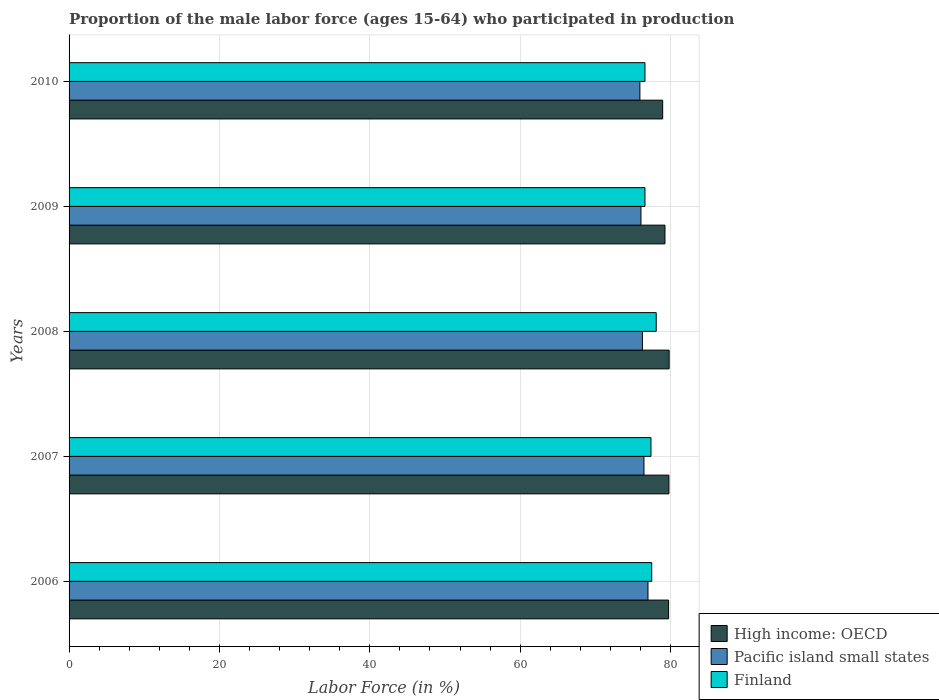How many groups of bars are there?
Your answer should be very brief. 5. Are the number of bars per tick equal to the number of legend labels?
Ensure brevity in your answer.  Yes. Are the number of bars on each tick of the Y-axis equal?
Your response must be concise. Yes. How many bars are there on the 3rd tick from the top?
Your answer should be very brief. 3. In how many cases, is the number of bars for a given year not equal to the number of legend labels?
Give a very brief answer. 0. What is the proportion of the male labor force who participated in production in Finland in 2008?
Offer a terse response. 78.1. Across all years, what is the maximum proportion of the male labor force who participated in production in Finland?
Your response must be concise. 78.1. Across all years, what is the minimum proportion of the male labor force who participated in production in High income: OECD?
Keep it short and to the point. 78.96. In which year was the proportion of the male labor force who participated in production in High income: OECD maximum?
Provide a succinct answer. 2008. What is the total proportion of the male labor force who participated in production in Finland in the graph?
Ensure brevity in your answer.  386.2. What is the difference between the proportion of the male labor force who participated in production in Pacific island small states in 2009 and that in 2010?
Your answer should be compact. 0.14. What is the difference between the proportion of the male labor force who participated in production in Pacific island small states in 2010 and the proportion of the male labor force who participated in production in High income: OECD in 2007?
Ensure brevity in your answer.  -3.86. What is the average proportion of the male labor force who participated in production in High income: OECD per year?
Keep it short and to the point. 79.52. In the year 2010, what is the difference between the proportion of the male labor force who participated in production in Finland and proportion of the male labor force who participated in production in High income: OECD?
Provide a succinct answer. -2.36. What is the ratio of the proportion of the male labor force who participated in production in Finland in 2006 to that in 2007?
Offer a terse response. 1. What is the difference between the highest and the second highest proportion of the male labor force who participated in production in Pacific island small states?
Offer a very short reply. 0.54. What is the difference between the highest and the lowest proportion of the male labor force who participated in production in Pacific island small states?
Ensure brevity in your answer.  1.08. What does the 2nd bar from the top in 2007 represents?
Give a very brief answer. Pacific island small states. What does the 1st bar from the bottom in 2010 represents?
Your answer should be compact. High income: OECD. How many bars are there?
Your response must be concise. 15. What is the difference between two consecutive major ticks on the X-axis?
Keep it short and to the point. 20. Are the values on the major ticks of X-axis written in scientific E-notation?
Provide a succinct answer. No. Does the graph contain any zero values?
Make the answer very short. No. Does the graph contain grids?
Give a very brief answer. Yes. Where does the legend appear in the graph?
Offer a terse response. Bottom right. How many legend labels are there?
Provide a succinct answer. 3. How are the legend labels stacked?
Your answer should be very brief. Vertical. What is the title of the graph?
Your answer should be very brief. Proportion of the male labor force (ages 15-64) who participated in production. Does "Saudi Arabia" appear as one of the legend labels in the graph?
Make the answer very short. No. What is the Labor Force (in %) in High income: OECD in 2006?
Provide a short and direct response. 79.75. What is the Labor Force (in %) of Pacific island small states in 2006?
Provide a succinct answer. 77. What is the Labor Force (in %) in Finland in 2006?
Provide a succinct answer. 77.5. What is the Labor Force (in %) in High income: OECD in 2007?
Ensure brevity in your answer.  79.79. What is the Labor Force (in %) of Pacific island small states in 2007?
Your answer should be compact. 76.47. What is the Labor Force (in %) in Finland in 2007?
Offer a very short reply. 77.4. What is the Labor Force (in %) in High income: OECD in 2008?
Your response must be concise. 79.82. What is the Labor Force (in %) of Pacific island small states in 2008?
Offer a very short reply. 76.26. What is the Labor Force (in %) in Finland in 2008?
Ensure brevity in your answer.  78.1. What is the Labor Force (in %) of High income: OECD in 2009?
Make the answer very short. 79.26. What is the Labor Force (in %) in Pacific island small states in 2009?
Your response must be concise. 76.07. What is the Labor Force (in %) in Finland in 2009?
Ensure brevity in your answer.  76.6. What is the Labor Force (in %) of High income: OECD in 2010?
Offer a very short reply. 78.96. What is the Labor Force (in %) in Pacific island small states in 2010?
Give a very brief answer. 75.93. What is the Labor Force (in %) of Finland in 2010?
Offer a very short reply. 76.6. Across all years, what is the maximum Labor Force (in %) in High income: OECD?
Provide a short and direct response. 79.82. Across all years, what is the maximum Labor Force (in %) of Pacific island small states?
Your answer should be very brief. 77. Across all years, what is the maximum Labor Force (in %) of Finland?
Offer a terse response. 78.1. Across all years, what is the minimum Labor Force (in %) of High income: OECD?
Make the answer very short. 78.96. Across all years, what is the minimum Labor Force (in %) of Pacific island small states?
Your answer should be very brief. 75.93. Across all years, what is the minimum Labor Force (in %) in Finland?
Make the answer very short. 76.6. What is the total Labor Force (in %) in High income: OECD in the graph?
Your answer should be very brief. 397.58. What is the total Labor Force (in %) in Pacific island small states in the graph?
Keep it short and to the point. 381.73. What is the total Labor Force (in %) of Finland in the graph?
Provide a short and direct response. 386.2. What is the difference between the Labor Force (in %) in High income: OECD in 2006 and that in 2007?
Your answer should be compact. -0.05. What is the difference between the Labor Force (in %) of Pacific island small states in 2006 and that in 2007?
Make the answer very short. 0.54. What is the difference between the Labor Force (in %) of Finland in 2006 and that in 2007?
Your response must be concise. 0.1. What is the difference between the Labor Force (in %) of High income: OECD in 2006 and that in 2008?
Give a very brief answer. -0.07. What is the difference between the Labor Force (in %) of Pacific island small states in 2006 and that in 2008?
Your answer should be compact. 0.74. What is the difference between the Labor Force (in %) in Finland in 2006 and that in 2008?
Provide a short and direct response. -0.6. What is the difference between the Labor Force (in %) in High income: OECD in 2006 and that in 2009?
Keep it short and to the point. 0.48. What is the difference between the Labor Force (in %) of Pacific island small states in 2006 and that in 2009?
Provide a succinct answer. 0.94. What is the difference between the Labor Force (in %) of High income: OECD in 2006 and that in 2010?
Offer a terse response. 0.79. What is the difference between the Labor Force (in %) in Pacific island small states in 2006 and that in 2010?
Your response must be concise. 1.08. What is the difference between the Labor Force (in %) of High income: OECD in 2007 and that in 2008?
Provide a short and direct response. -0.03. What is the difference between the Labor Force (in %) of Pacific island small states in 2007 and that in 2008?
Your answer should be compact. 0.21. What is the difference between the Labor Force (in %) in Finland in 2007 and that in 2008?
Provide a short and direct response. -0.7. What is the difference between the Labor Force (in %) of High income: OECD in 2007 and that in 2009?
Your response must be concise. 0.53. What is the difference between the Labor Force (in %) in Pacific island small states in 2007 and that in 2009?
Give a very brief answer. 0.4. What is the difference between the Labor Force (in %) of High income: OECD in 2007 and that in 2010?
Offer a terse response. 0.83. What is the difference between the Labor Force (in %) in Pacific island small states in 2007 and that in 2010?
Your answer should be compact. 0.54. What is the difference between the Labor Force (in %) in Finland in 2007 and that in 2010?
Your answer should be very brief. 0.8. What is the difference between the Labor Force (in %) in High income: OECD in 2008 and that in 2009?
Make the answer very short. 0.56. What is the difference between the Labor Force (in %) of Pacific island small states in 2008 and that in 2009?
Provide a short and direct response. 0.19. What is the difference between the Labor Force (in %) in Finland in 2008 and that in 2009?
Offer a very short reply. 1.5. What is the difference between the Labor Force (in %) of High income: OECD in 2008 and that in 2010?
Give a very brief answer. 0.86. What is the difference between the Labor Force (in %) in Pacific island small states in 2008 and that in 2010?
Make the answer very short. 0.34. What is the difference between the Labor Force (in %) in High income: OECD in 2009 and that in 2010?
Provide a short and direct response. 0.31. What is the difference between the Labor Force (in %) of Pacific island small states in 2009 and that in 2010?
Offer a terse response. 0.14. What is the difference between the Labor Force (in %) in Finland in 2009 and that in 2010?
Your response must be concise. 0. What is the difference between the Labor Force (in %) in High income: OECD in 2006 and the Labor Force (in %) in Pacific island small states in 2007?
Provide a short and direct response. 3.28. What is the difference between the Labor Force (in %) in High income: OECD in 2006 and the Labor Force (in %) in Finland in 2007?
Your response must be concise. 2.35. What is the difference between the Labor Force (in %) in Pacific island small states in 2006 and the Labor Force (in %) in Finland in 2007?
Provide a short and direct response. -0.4. What is the difference between the Labor Force (in %) of High income: OECD in 2006 and the Labor Force (in %) of Pacific island small states in 2008?
Provide a succinct answer. 3.48. What is the difference between the Labor Force (in %) of High income: OECD in 2006 and the Labor Force (in %) of Finland in 2008?
Provide a short and direct response. 1.65. What is the difference between the Labor Force (in %) of Pacific island small states in 2006 and the Labor Force (in %) of Finland in 2008?
Keep it short and to the point. -1.1. What is the difference between the Labor Force (in %) of High income: OECD in 2006 and the Labor Force (in %) of Pacific island small states in 2009?
Provide a short and direct response. 3.68. What is the difference between the Labor Force (in %) in High income: OECD in 2006 and the Labor Force (in %) in Finland in 2009?
Provide a short and direct response. 3.15. What is the difference between the Labor Force (in %) in Pacific island small states in 2006 and the Labor Force (in %) in Finland in 2009?
Ensure brevity in your answer.  0.4. What is the difference between the Labor Force (in %) in High income: OECD in 2006 and the Labor Force (in %) in Pacific island small states in 2010?
Give a very brief answer. 3.82. What is the difference between the Labor Force (in %) in High income: OECD in 2006 and the Labor Force (in %) in Finland in 2010?
Provide a short and direct response. 3.15. What is the difference between the Labor Force (in %) in Pacific island small states in 2006 and the Labor Force (in %) in Finland in 2010?
Your answer should be very brief. 0.4. What is the difference between the Labor Force (in %) in High income: OECD in 2007 and the Labor Force (in %) in Pacific island small states in 2008?
Give a very brief answer. 3.53. What is the difference between the Labor Force (in %) of High income: OECD in 2007 and the Labor Force (in %) of Finland in 2008?
Keep it short and to the point. 1.69. What is the difference between the Labor Force (in %) of Pacific island small states in 2007 and the Labor Force (in %) of Finland in 2008?
Make the answer very short. -1.63. What is the difference between the Labor Force (in %) in High income: OECD in 2007 and the Labor Force (in %) in Pacific island small states in 2009?
Give a very brief answer. 3.72. What is the difference between the Labor Force (in %) of High income: OECD in 2007 and the Labor Force (in %) of Finland in 2009?
Keep it short and to the point. 3.19. What is the difference between the Labor Force (in %) of Pacific island small states in 2007 and the Labor Force (in %) of Finland in 2009?
Make the answer very short. -0.13. What is the difference between the Labor Force (in %) of High income: OECD in 2007 and the Labor Force (in %) of Pacific island small states in 2010?
Offer a very short reply. 3.86. What is the difference between the Labor Force (in %) in High income: OECD in 2007 and the Labor Force (in %) in Finland in 2010?
Keep it short and to the point. 3.19. What is the difference between the Labor Force (in %) in Pacific island small states in 2007 and the Labor Force (in %) in Finland in 2010?
Provide a short and direct response. -0.13. What is the difference between the Labor Force (in %) in High income: OECD in 2008 and the Labor Force (in %) in Pacific island small states in 2009?
Your response must be concise. 3.75. What is the difference between the Labor Force (in %) in High income: OECD in 2008 and the Labor Force (in %) in Finland in 2009?
Provide a succinct answer. 3.22. What is the difference between the Labor Force (in %) in Pacific island small states in 2008 and the Labor Force (in %) in Finland in 2009?
Offer a terse response. -0.34. What is the difference between the Labor Force (in %) of High income: OECD in 2008 and the Labor Force (in %) of Pacific island small states in 2010?
Offer a terse response. 3.89. What is the difference between the Labor Force (in %) in High income: OECD in 2008 and the Labor Force (in %) in Finland in 2010?
Ensure brevity in your answer.  3.22. What is the difference between the Labor Force (in %) of Pacific island small states in 2008 and the Labor Force (in %) of Finland in 2010?
Your answer should be very brief. -0.34. What is the difference between the Labor Force (in %) in High income: OECD in 2009 and the Labor Force (in %) in Pacific island small states in 2010?
Your response must be concise. 3.34. What is the difference between the Labor Force (in %) of High income: OECD in 2009 and the Labor Force (in %) of Finland in 2010?
Make the answer very short. 2.66. What is the difference between the Labor Force (in %) of Pacific island small states in 2009 and the Labor Force (in %) of Finland in 2010?
Your response must be concise. -0.53. What is the average Labor Force (in %) in High income: OECD per year?
Your answer should be compact. 79.52. What is the average Labor Force (in %) of Pacific island small states per year?
Offer a terse response. 76.35. What is the average Labor Force (in %) of Finland per year?
Give a very brief answer. 77.24. In the year 2006, what is the difference between the Labor Force (in %) in High income: OECD and Labor Force (in %) in Pacific island small states?
Keep it short and to the point. 2.74. In the year 2006, what is the difference between the Labor Force (in %) in High income: OECD and Labor Force (in %) in Finland?
Your answer should be compact. 2.25. In the year 2006, what is the difference between the Labor Force (in %) of Pacific island small states and Labor Force (in %) of Finland?
Provide a succinct answer. -0.5. In the year 2007, what is the difference between the Labor Force (in %) of High income: OECD and Labor Force (in %) of Pacific island small states?
Your response must be concise. 3.32. In the year 2007, what is the difference between the Labor Force (in %) of High income: OECD and Labor Force (in %) of Finland?
Provide a succinct answer. 2.39. In the year 2007, what is the difference between the Labor Force (in %) of Pacific island small states and Labor Force (in %) of Finland?
Offer a terse response. -0.93. In the year 2008, what is the difference between the Labor Force (in %) in High income: OECD and Labor Force (in %) in Pacific island small states?
Provide a short and direct response. 3.56. In the year 2008, what is the difference between the Labor Force (in %) in High income: OECD and Labor Force (in %) in Finland?
Give a very brief answer. 1.72. In the year 2008, what is the difference between the Labor Force (in %) in Pacific island small states and Labor Force (in %) in Finland?
Make the answer very short. -1.84. In the year 2009, what is the difference between the Labor Force (in %) in High income: OECD and Labor Force (in %) in Pacific island small states?
Your answer should be very brief. 3.2. In the year 2009, what is the difference between the Labor Force (in %) in High income: OECD and Labor Force (in %) in Finland?
Give a very brief answer. 2.66. In the year 2009, what is the difference between the Labor Force (in %) in Pacific island small states and Labor Force (in %) in Finland?
Your answer should be very brief. -0.53. In the year 2010, what is the difference between the Labor Force (in %) of High income: OECD and Labor Force (in %) of Pacific island small states?
Your answer should be very brief. 3.03. In the year 2010, what is the difference between the Labor Force (in %) in High income: OECD and Labor Force (in %) in Finland?
Ensure brevity in your answer.  2.36. In the year 2010, what is the difference between the Labor Force (in %) in Pacific island small states and Labor Force (in %) in Finland?
Provide a succinct answer. -0.67. What is the ratio of the Labor Force (in %) of High income: OECD in 2006 to that in 2007?
Provide a short and direct response. 1. What is the ratio of the Labor Force (in %) of Finland in 2006 to that in 2007?
Make the answer very short. 1. What is the ratio of the Labor Force (in %) of High income: OECD in 2006 to that in 2008?
Keep it short and to the point. 1. What is the ratio of the Labor Force (in %) in Pacific island small states in 2006 to that in 2008?
Ensure brevity in your answer.  1.01. What is the ratio of the Labor Force (in %) in Finland in 2006 to that in 2008?
Provide a short and direct response. 0.99. What is the ratio of the Labor Force (in %) in Pacific island small states in 2006 to that in 2009?
Offer a very short reply. 1.01. What is the ratio of the Labor Force (in %) of Finland in 2006 to that in 2009?
Ensure brevity in your answer.  1.01. What is the ratio of the Labor Force (in %) of Pacific island small states in 2006 to that in 2010?
Keep it short and to the point. 1.01. What is the ratio of the Labor Force (in %) in Finland in 2006 to that in 2010?
Your answer should be compact. 1.01. What is the ratio of the Labor Force (in %) of Pacific island small states in 2007 to that in 2009?
Offer a terse response. 1.01. What is the ratio of the Labor Force (in %) of Finland in 2007 to that in 2009?
Ensure brevity in your answer.  1.01. What is the ratio of the Labor Force (in %) of High income: OECD in 2007 to that in 2010?
Provide a short and direct response. 1.01. What is the ratio of the Labor Force (in %) of Pacific island small states in 2007 to that in 2010?
Your answer should be very brief. 1.01. What is the ratio of the Labor Force (in %) of Finland in 2007 to that in 2010?
Give a very brief answer. 1.01. What is the ratio of the Labor Force (in %) in Pacific island small states in 2008 to that in 2009?
Provide a succinct answer. 1. What is the ratio of the Labor Force (in %) of Finland in 2008 to that in 2009?
Provide a short and direct response. 1.02. What is the ratio of the Labor Force (in %) in High income: OECD in 2008 to that in 2010?
Offer a very short reply. 1.01. What is the ratio of the Labor Force (in %) in Finland in 2008 to that in 2010?
Provide a short and direct response. 1.02. What is the difference between the highest and the second highest Labor Force (in %) of High income: OECD?
Your response must be concise. 0.03. What is the difference between the highest and the second highest Labor Force (in %) in Pacific island small states?
Ensure brevity in your answer.  0.54. What is the difference between the highest and the second highest Labor Force (in %) of Finland?
Your answer should be very brief. 0.6. What is the difference between the highest and the lowest Labor Force (in %) in High income: OECD?
Keep it short and to the point. 0.86. What is the difference between the highest and the lowest Labor Force (in %) of Pacific island small states?
Provide a succinct answer. 1.08. What is the difference between the highest and the lowest Labor Force (in %) in Finland?
Offer a very short reply. 1.5. 